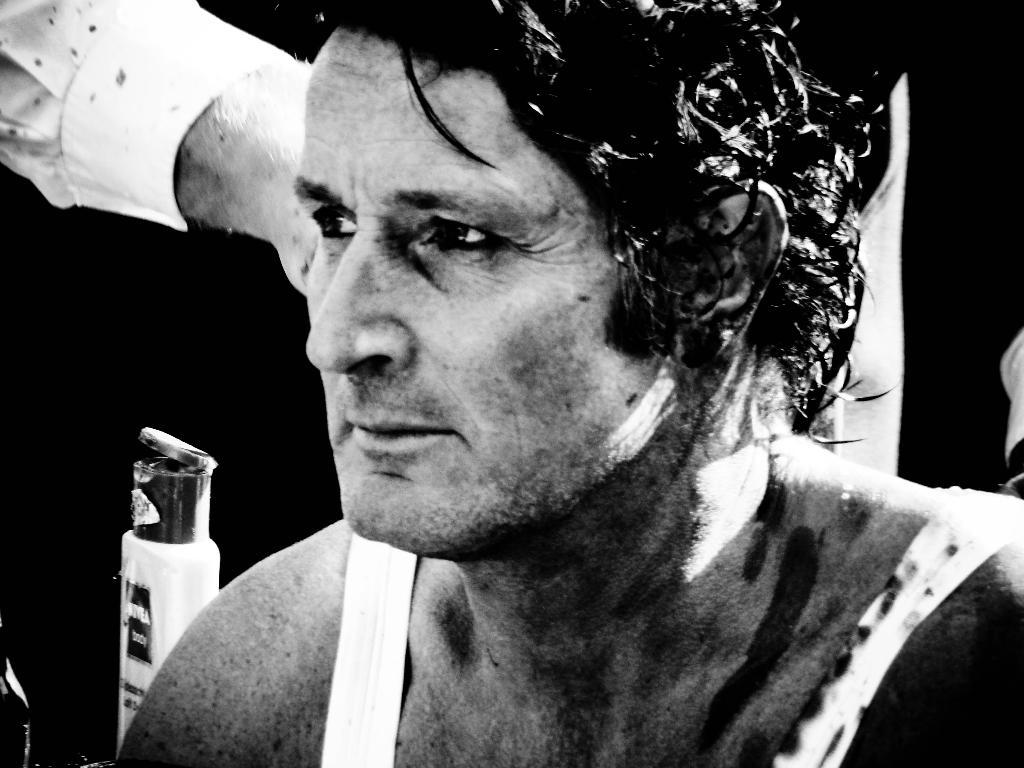What is the color scheme of the image? The image is black and white. Can you describe the main subject in the image? There is a man in the image. What type of linen is being used by the committee at the school in the image? There is no mention of linen, committee, or school in the image; it only features a man in a black and white setting. 